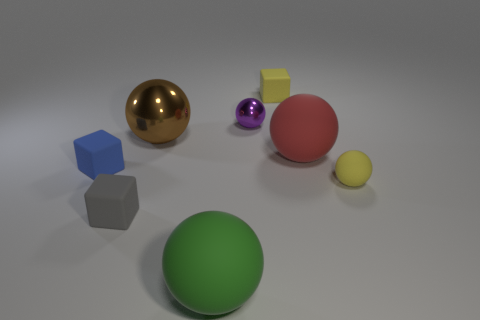There is a ball that is in front of the gray cube; does it have the same color as the small matte ball?
Offer a terse response. No. What number of things are tiny matte spheres or tiny cyan cylinders?
Provide a succinct answer. 1. There is a cube that is right of the big green sphere; what is its color?
Provide a succinct answer. Yellow. Is the number of rubber cubes in front of the small gray thing less than the number of blue rubber blocks?
Provide a succinct answer. Yes. What size is the matte block that is the same color as the small rubber ball?
Your answer should be compact. Small. Is there anything else that has the same size as the yellow matte sphere?
Offer a very short reply. Yes. Does the small yellow cube have the same material as the tiny blue object?
Ensure brevity in your answer.  Yes. How many things are objects on the left side of the red rubber ball or blocks that are to the left of the large brown shiny thing?
Ensure brevity in your answer.  6. Is there a blue matte block of the same size as the gray rubber block?
Offer a terse response. Yes. What is the color of the tiny rubber object that is the same shape as the large red thing?
Keep it short and to the point. Yellow. 